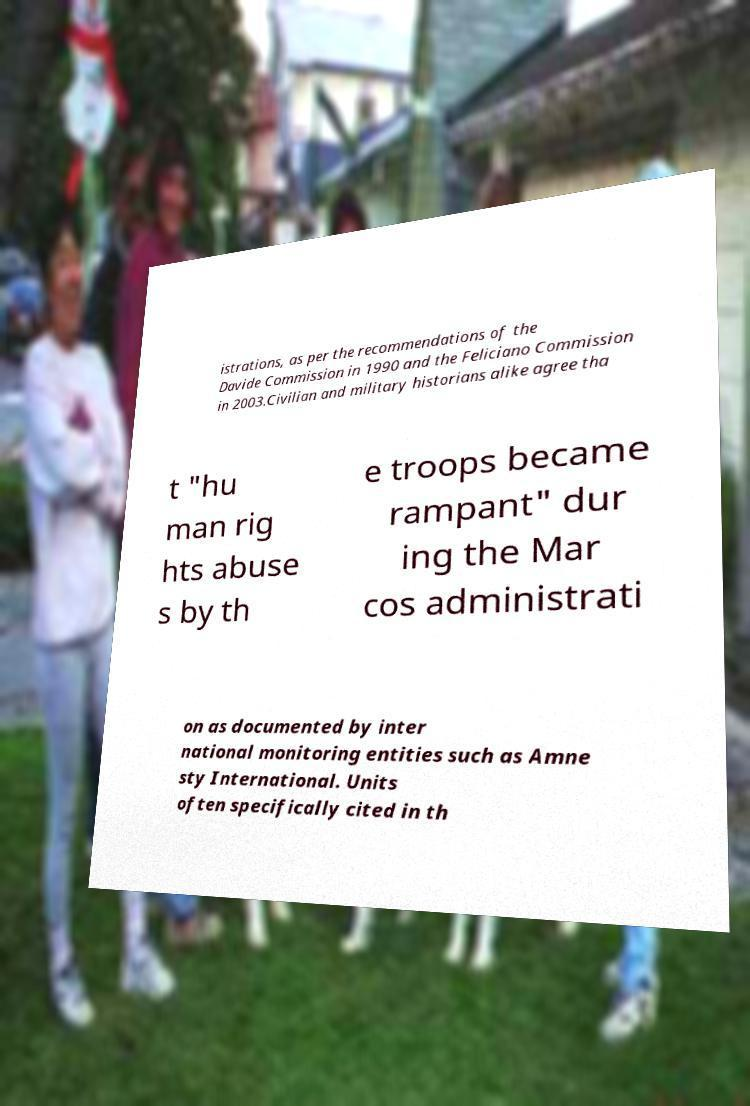For documentation purposes, I need the text within this image transcribed. Could you provide that? istrations, as per the recommendations of the Davide Commission in 1990 and the Feliciano Commission in 2003.Civilian and military historians alike agree tha t "hu man rig hts abuse s by th e troops became rampant" dur ing the Mar cos administrati on as documented by inter national monitoring entities such as Amne sty International. Units often specifically cited in th 